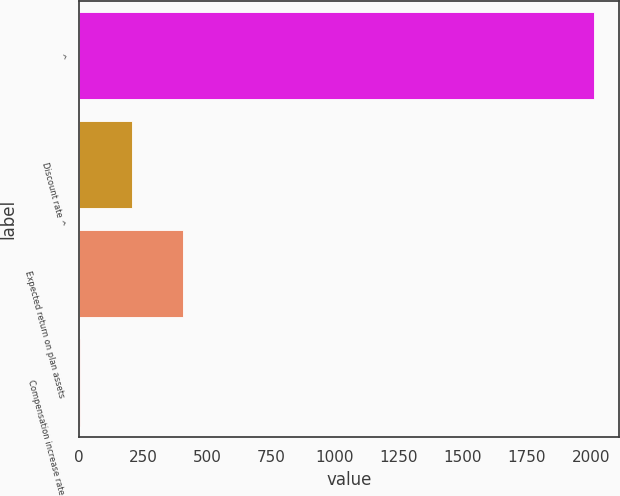<chart> <loc_0><loc_0><loc_500><loc_500><bar_chart><fcel>^<fcel>Discount rate ^<fcel>Expected return on plan assets<fcel>Compensation increase rate<nl><fcel>2011<fcel>205.15<fcel>405.8<fcel>4.5<nl></chart> 